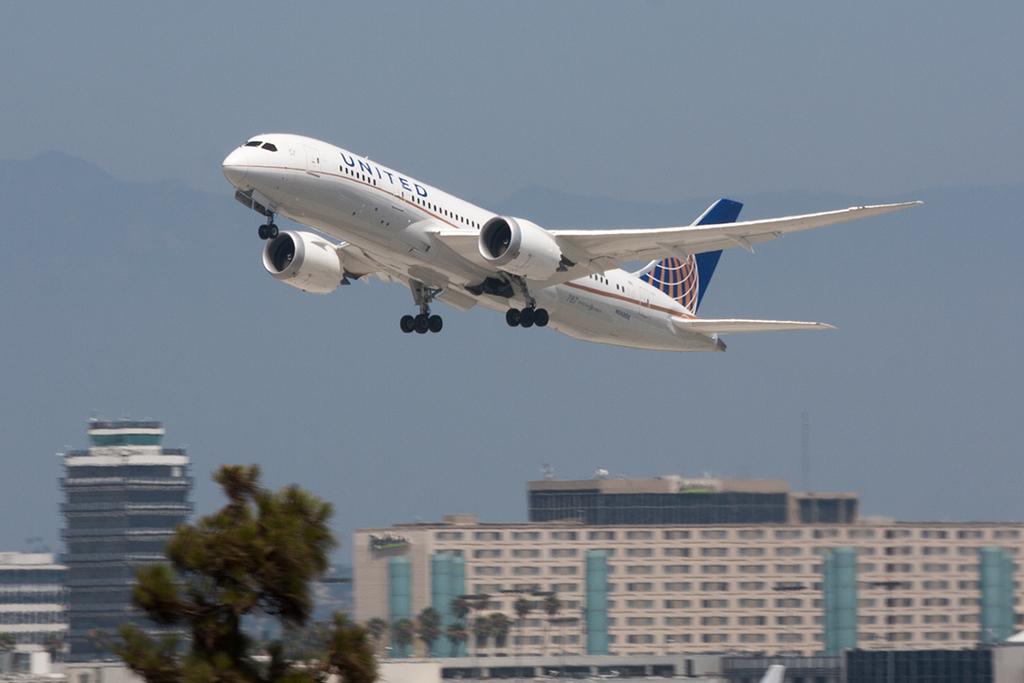What is the name of the airline of the commercial jet?
Make the answer very short. United. 